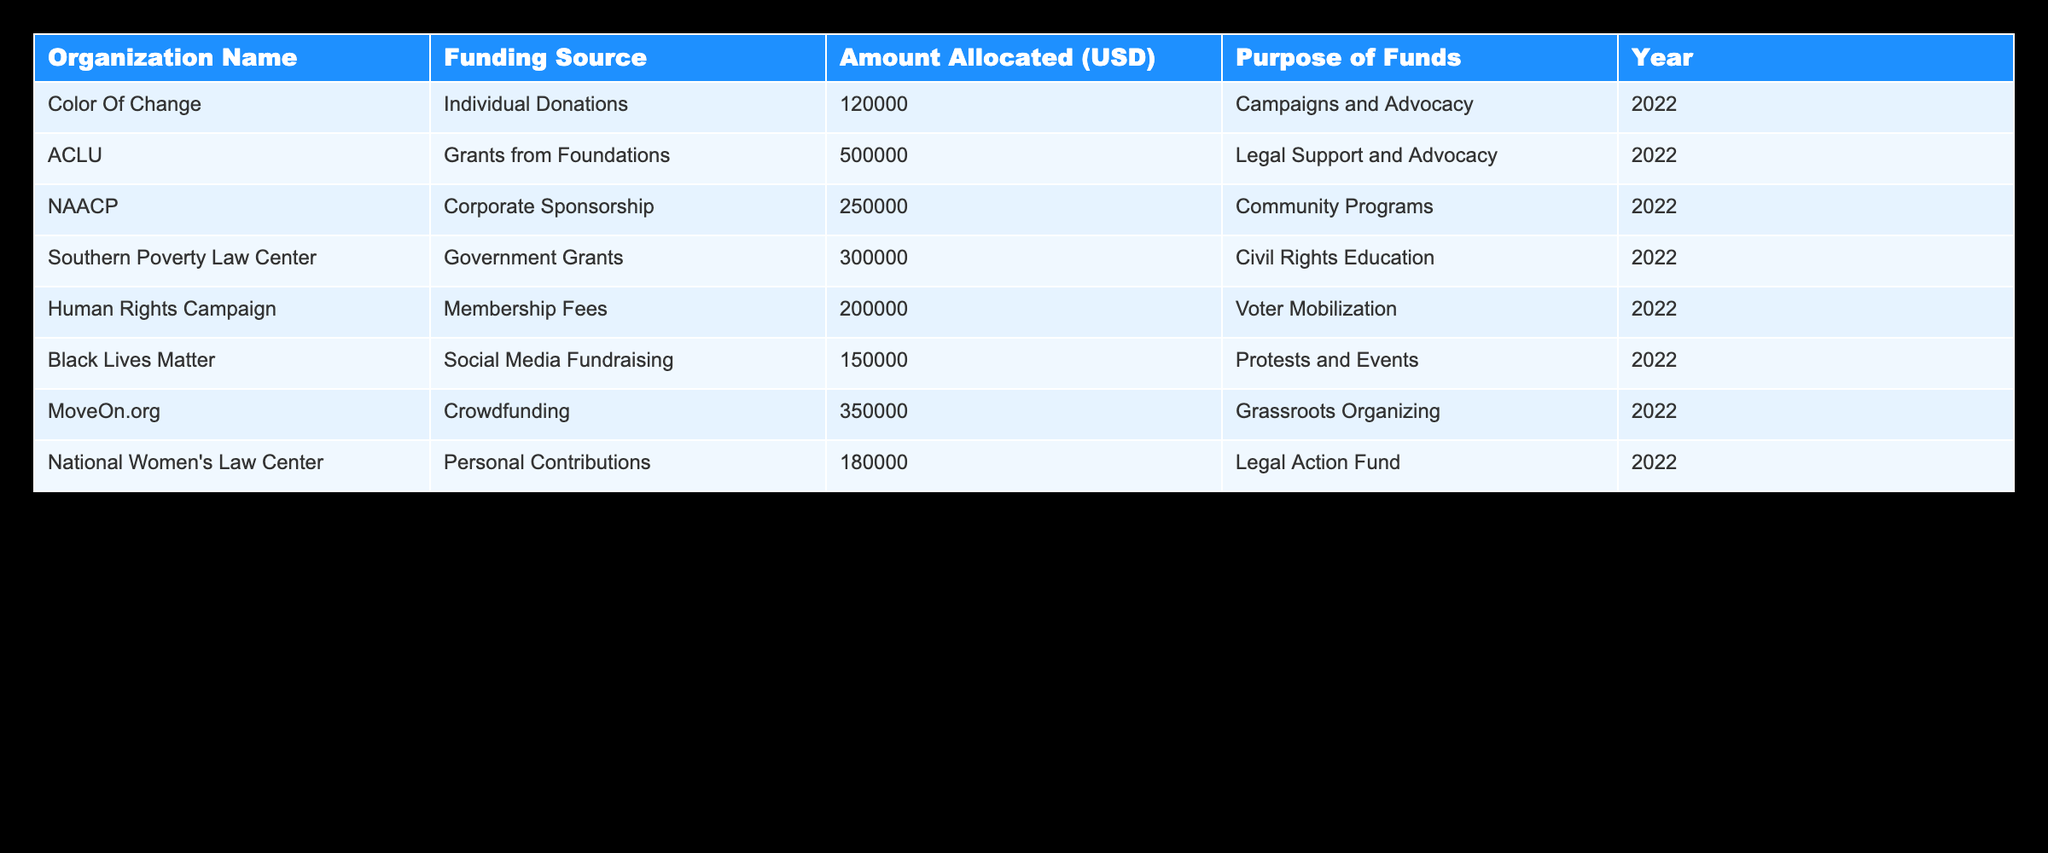What is the total amount allocated to ACLU? The table shows that ACLU has an allocation of 500000 USD under the "Grants from Foundations" funding source for the purpose of "Legal Support and Advocacy". Therefore, the total amount allocated to ACLU is 500000 USD.
Answer: 500000 Which organization received the least amount of funding? Looking at the amounts allocated, the organization with the smallest allocation is Black Lives Matter, which received 150000 USD from "Social Media Fundraising".
Answer: Black Lives Matter What is the total amount allocated to all organizations listed in the table? To find the total, add the amounts allocated for each organization: 120000 + 500000 + 250000 + 300000 + 200000 + 150000 + 350000 + 180000 = 2050000 USD. Therefore, the total amount allocated is 2050000 USD.
Answer: 2050000 Are there any organizations funded through government grants? The table indicates that the Southern Poverty Law Center received 300000 USD from government grants for "Civil Rights Education". Thus, there is at least one organization funded through government grants.
Answer: Yes What is the average amount allocated to organizations from corporate sponsorships? There is one organization listed that received corporate sponsorship: NAACP, which was allocated 250000 USD. Since there's only one organization, the average amount is equal to this single allocation, which is 250000 USD.
Answer: 250000 Which purposes received the most funding, and how much was allocated for that purpose? Reviewing the purposes, "Legal Support and Advocacy" received the highest amount of funding, totaling 500000 USD allocated to ACLU.
Answer: Legal Support and Advocacy; 500000 Is it true that all organizations listed received financial support from a single source? The table shows various organizations funded by multiple sources, such as individual donations, grants from foundations, corporate sponsorship, and more. Therefore, not every organization is funded by a single source.
Answer: No How much funding did organizations receive from individual donations in total? The only organization listed that received funding from individual donations is Color Of Change, which received 120000 USD. Therefore, the total amount from individual donations is 120000 USD.
Answer: 120000 